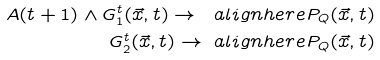<formula> <loc_0><loc_0><loc_500><loc_500>A ( t + 1 ) \wedge G _ { 1 } ^ { t } ( \vec { x } , t ) \rightarrow \ a l i g n h e r e P _ { Q } ( \vec { x } , t ) \\ G _ { 2 } ^ { t } ( \vec { x } , t ) \rightarrow \ a l i g n h e r e P _ { Q } ( \vec { x } , t )</formula> 